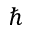Convert formula to latex. <formula><loc_0><loc_0><loc_500><loc_500>\hbar</formula> 